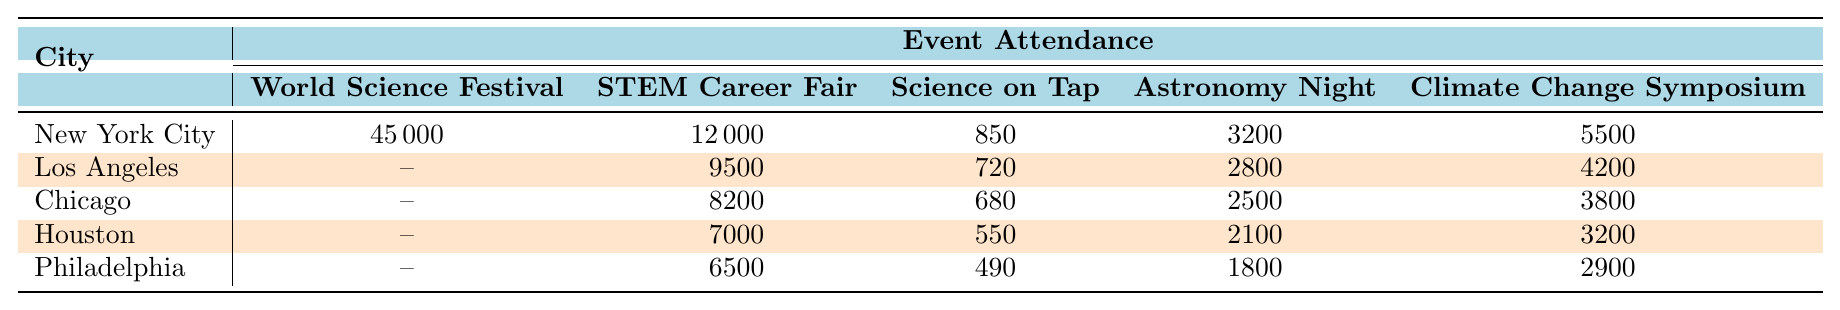What is the attendance for the World Science Festival in New York City? The table lists the attendance for each event by city, and for New York City, the attendance for the World Science Festival is given as 45000.
Answer: 45000 Which city had the highest attendance at the STEM Career Fair? By looking at the attendance numbers for the STEM Career Fair, New York City has an attendance of 12000, while Los Angeles, Chicago, Houston, and Philadelphia have lower values (9500, 8200, 7000, and 6500 respectively). Therefore, New York City had the highest attendance.
Answer: New York City What is the total attendance for the Climate Change Symposium across all cities? To find the total attendance for the Climate Change Symposium, sum the attendance for each city: 5500 (NYC) + 4200 (LA) + 3800 (Chicago) + 3200 (Houston) + 2900 (Philadelphia) = 19600.
Answer: 19600 Is the attendance for Science on Tap higher in Los Angeles or Philadelphia? The attendance for Science on Tap in Los Angeles is 720, while in Philadelphia, it is 490. Since 720 > 490, the attendance is higher in Los Angeles.
Answer: Yes, in Los Angeles What is the average attendance for Astronomy Night across all cities? The attendance for Astronomy Night is: 3200 (NYC) + 2800 (LA) + 2500 (Chicago) + 2100 (Houston) + 1800 (Philadelphia). The total is 12400, and there are 5 cities, so the average is 12400/5 = 2480.
Answer: 2480 Which event had the lowest attendance in Chicago? Examining the attendance figures for Chicago, the values are: World Science Festival (not available), STEM Career Fair (8200), Science on Tap (680), Astronomy Night (2500), and Climate Change Symposium (3800). The lowest attendance is for Science on Tap at 680.
Answer: Science on Tap Calculate the difference in attendance between the highest and lowest attended events in New York City. In New York City, the highest attendance is for the World Science Festival at 45000, and the lowest is for Science on Tap at 850. The difference is 45000 - 850 = 44150.
Answer: 44150 Is it true that all the cities had participation in the STEM Career Fair? The table shows that every city except New York City has attendance figures for the STEM Career Fair, therefore it is not true.
Answer: No, it's not true Which city has the most events with participation over 2000 individuals? Looking at the attendance data, New York City has all events over 2000 except for Science on Tap, while other cities have fewer events with participation over that threshold. Hence, New York City has the most events over 2000.
Answer: New York City What percentage of the total attendance in Houston is represented by the attendance at the SCIENCE ON TAP event? The total attendance in Houston is 7000 (STEM Career Fair) + 550 (Science on Tap) + 2100 (Astronomy Night) + 3200 (Climate Change Symposium) = 12850. The percentage for Science on Tap is (550/12850) * 100 ≈ 4.29%.
Answer: Approximately 4.29% 